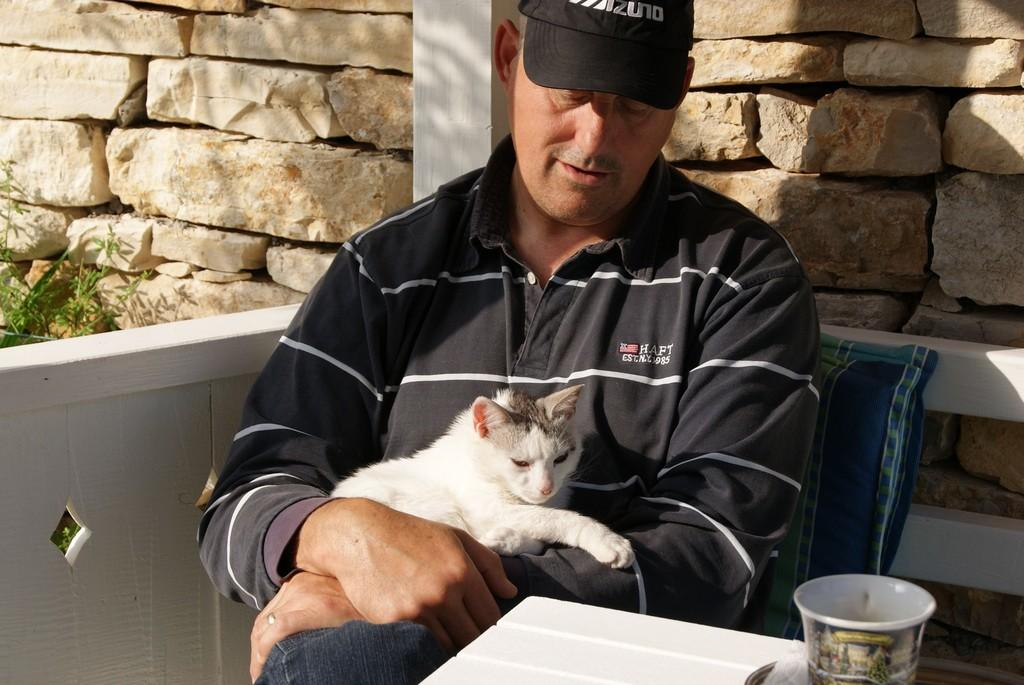What is the person in the image doing? The person is sitting on a chair. What is the person holding in the image? The person is holding a cat. What object can be seen in the image besides the person and the cat? There is a cup in the image. What can be seen in the background of the image? There is a wall in the background. What type of vegetation is present in the image? There is a plant in the image. What type of committee is meeting in the image? There is no committee meeting in the image; it features a person sitting on a chair holding a cat. What type of fan is visible in the image? There is no fan present in the image. 